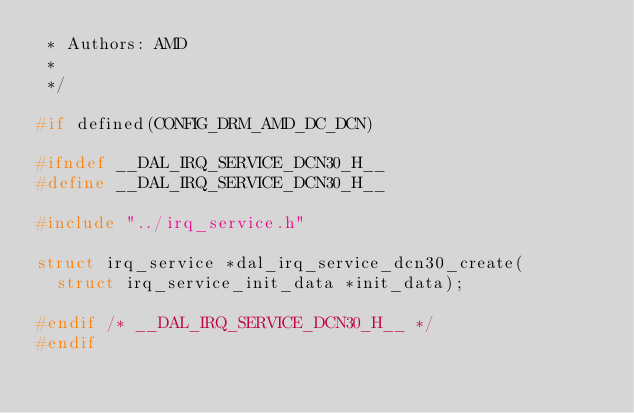Convert code to text. <code><loc_0><loc_0><loc_500><loc_500><_C_> * Authors: AMD
 *
 */

#if defined(CONFIG_DRM_AMD_DC_DCN)

#ifndef __DAL_IRQ_SERVICE_DCN30_H__
#define __DAL_IRQ_SERVICE_DCN30_H__

#include "../irq_service.h"

struct irq_service *dal_irq_service_dcn30_create(
	struct irq_service_init_data *init_data);

#endif /* __DAL_IRQ_SERVICE_DCN30_H__ */
#endif
</code> 